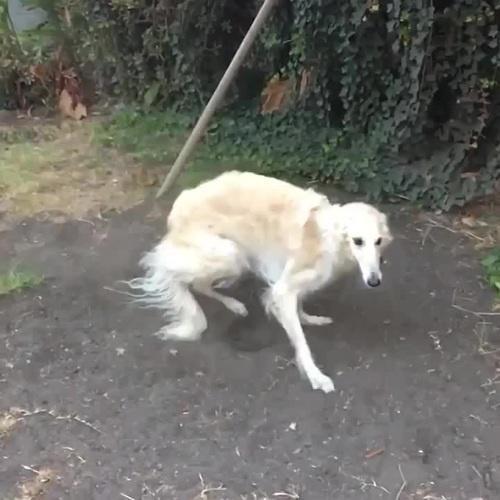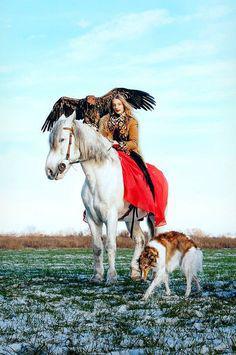The first image is the image on the left, the second image is the image on the right. Considering the images on both sides, is "The combined images include a person near a dog and a dog next to a horse." valid? Answer yes or no. Yes. The first image is the image on the left, the second image is the image on the right. Analyze the images presented: Is the assertion "There is a horse and two dogs staring in the same direction" valid? Answer yes or no. No. 